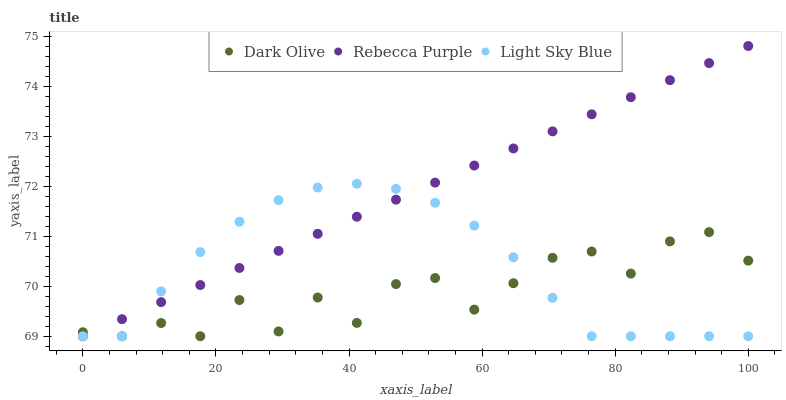Does Dark Olive have the minimum area under the curve?
Answer yes or no. Yes. Does Rebecca Purple have the maximum area under the curve?
Answer yes or no. Yes. Does Light Sky Blue have the minimum area under the curve?
Answer yes or no. No. Does Light Sky Blue have the maximum area under the curve?
Answer yes or no. No. Is Rebecca Purple the smoothest?
Answer yes or no. Yes. Is Dark Olive the roughest?
Answer yes or no. Yes. Is Light Sky Blue the smoothest?
Answer yes or no. No. Is Light Sky Blue the roughest?
Answer yes or no. No. Does Dark Olive have the lowest value?
Answer yes or no. Yes. Does Rebecca Purple have the highest value?
Answer yes or no. Yes. Does Light Sky Blue have the highest value?
Answer yes or no. No. Does Light Sky Blue intersect Dark Olive?
Answer yes or no. Yes. Is Light Sky Blue less than Dark Olive?
Answer yes or no. No. Is Light Sky Blue greater than Dark Olive?
Answer yes or no. No. 